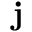<formula> <loc_0><loc_0><loc_500><loc_500>j</formula> 